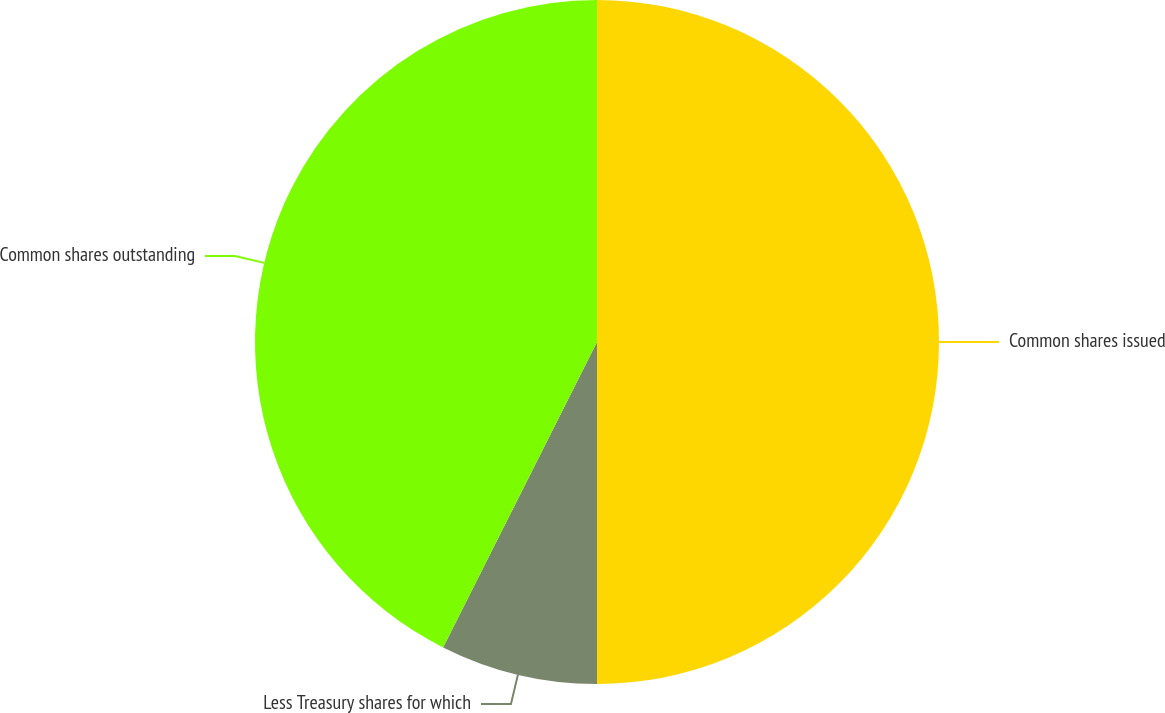Convert chart. <chart><loc_0><loc_0><loc_500><loc_500><pie_chart><fcel>Common shares issued<fcel>Less Treasury shares for which<fcel>Common shares outstanding<nl><fcel>50.0%<fcel>7.43%<fcel>42.57%<nl></chart> 